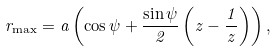<formula> <loc_0><loc_0><loc_500><loc_500>r _ { \max } = a \left ( \cos \psi + \frac { \sin \psi } 2 \left ( z - \frac { 1 } { z } \right ) \right ) ,</formula> 